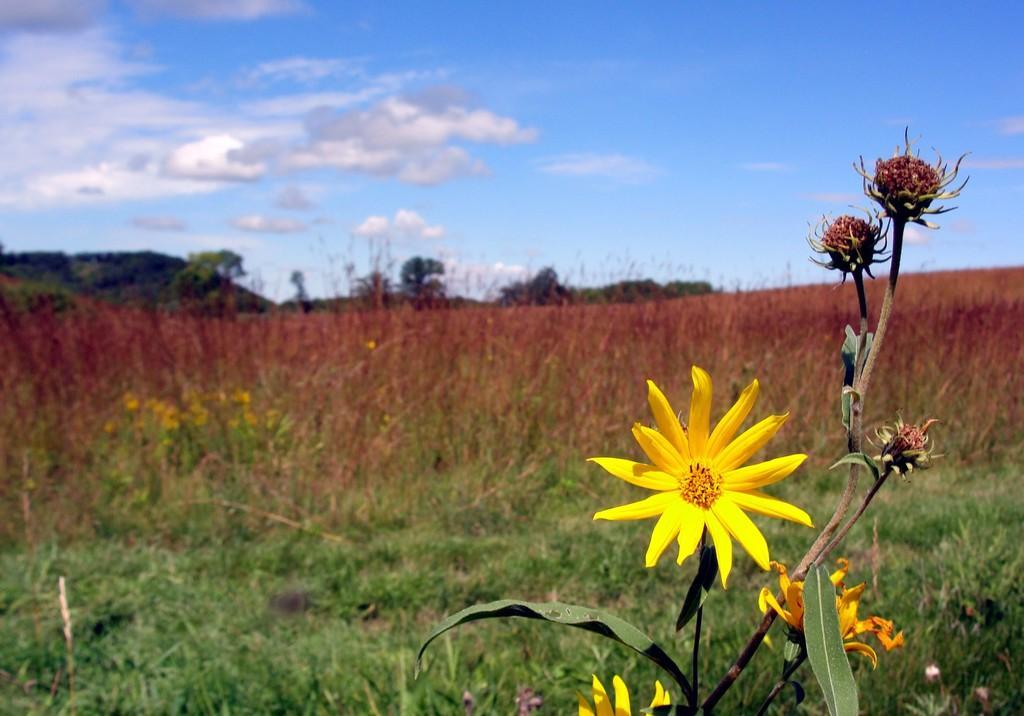Please provide a concise description of this image. In this picture we can see some flowers to the plant, behind we can see some plants, grass, trees and we can see cloudy sky. 